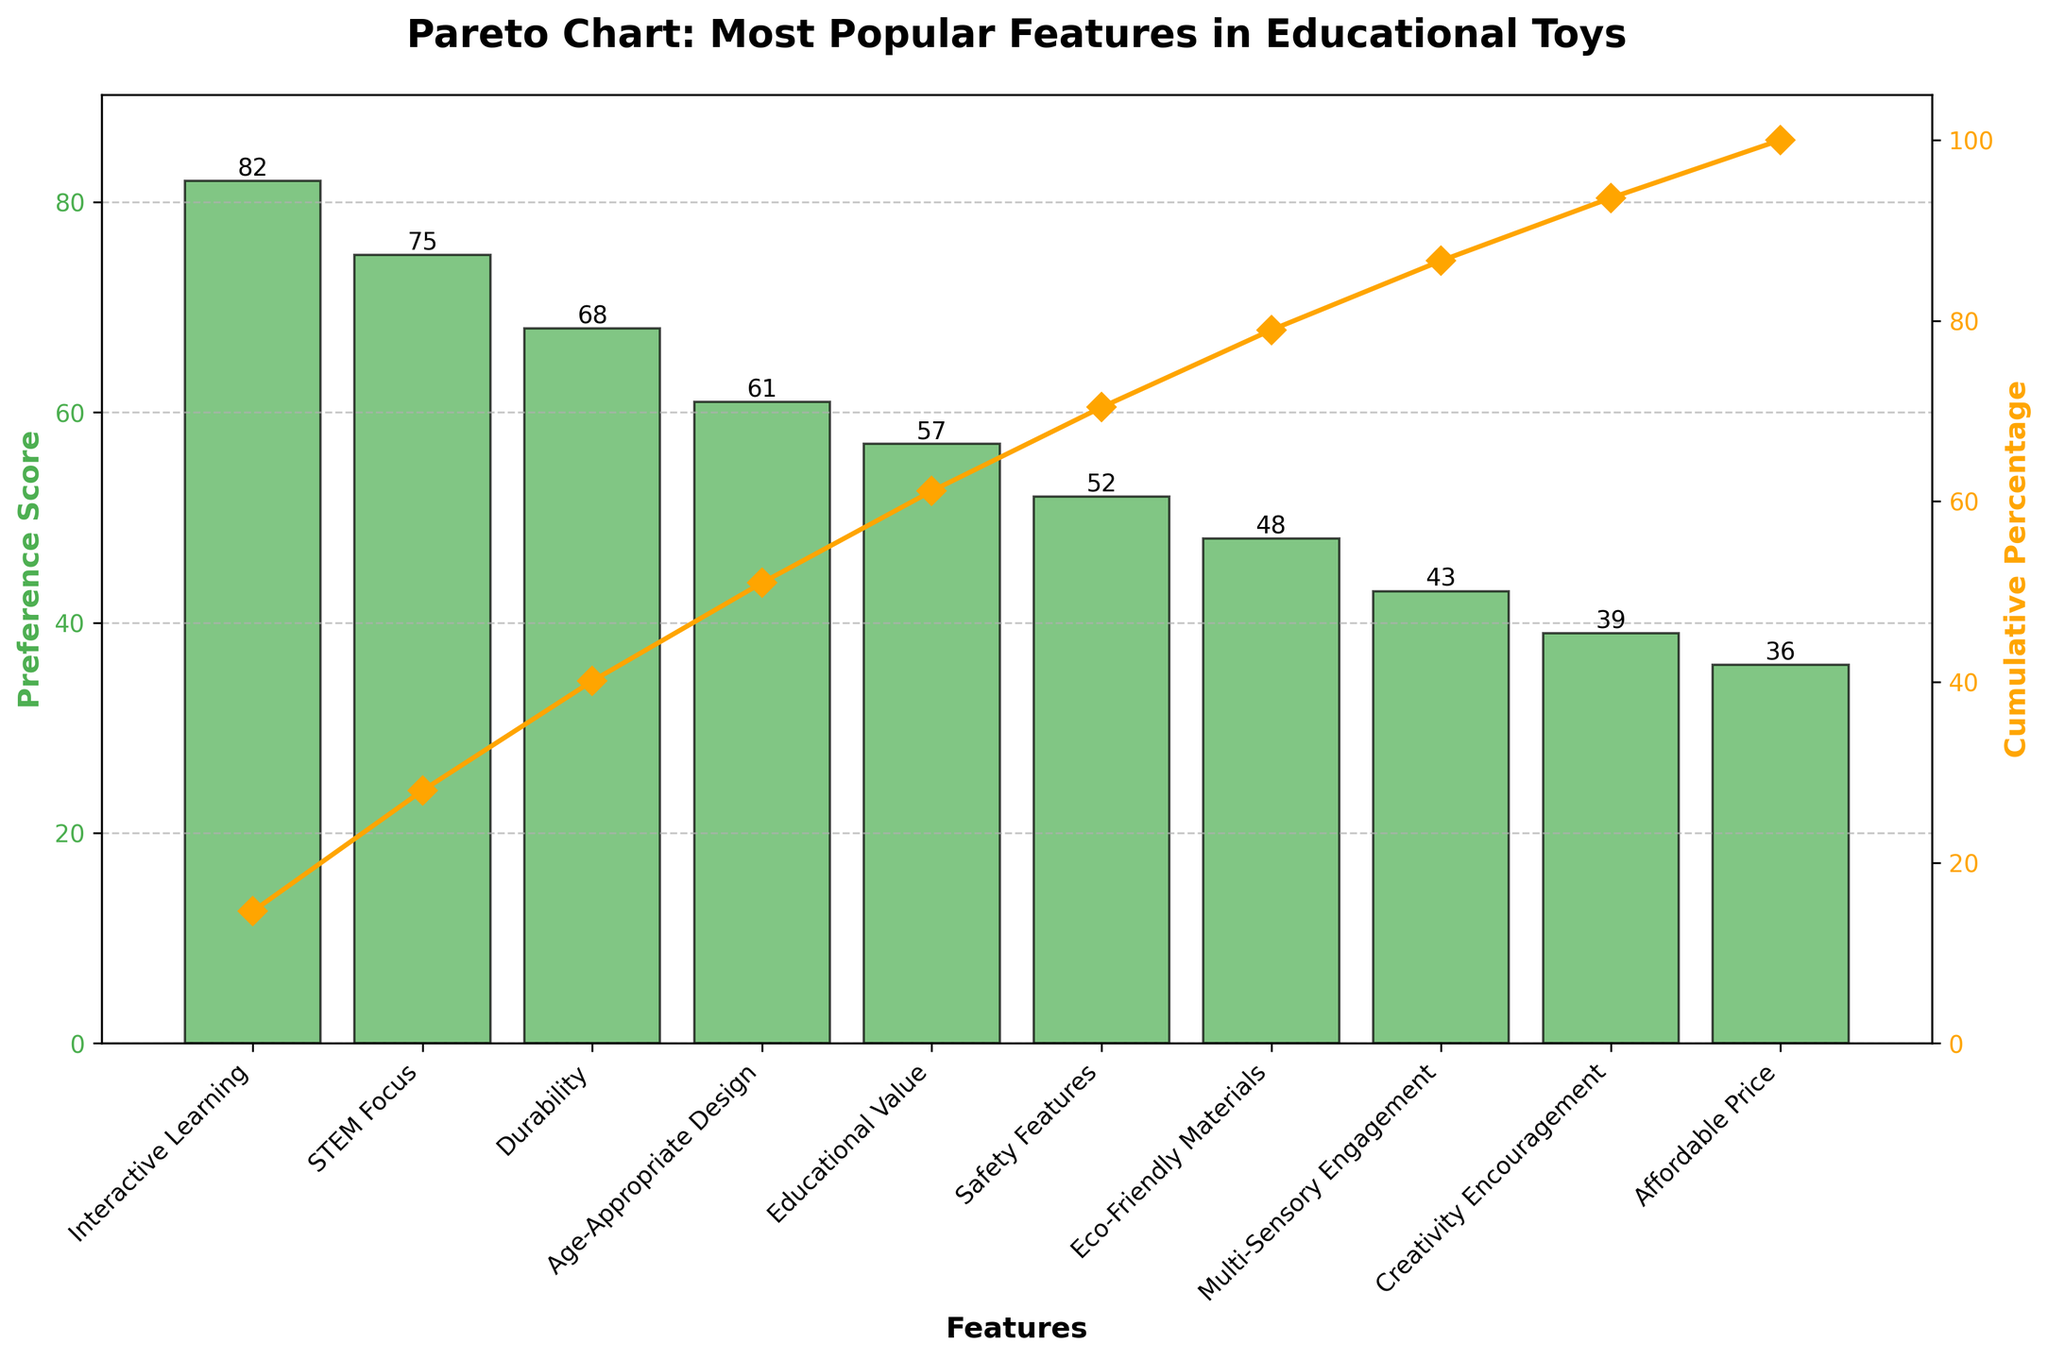What is the title of the chart? The title is the text at the top of the chart that explains its purpose or subject. In this case, it says "Pareto Chart: Most Popular Features in Educational Toys".
Answer: Pareto Chart: Most Popular Features in Educational Toys What feature has the highest preference score? The highest bar on the chart represents the feature with the highest preference score. The bar for "Interactive Learning" is the tallest.
Answer: Interactive Learning What are the colors used for the bars and the line? The bars are filled with one color, and the line is another color. The bars are green, while the line is orange.
Answer: Green and orange Which feature has a preference score of 75? Look for the bar reaching up to the score of 75 on the y-axis. The feature listed directly below this bar is "STEM Focus".
Answer: STEM Focus What is the sum of the preference scores for the top three features? To find the sum, add the preference scores of "Interactive Learning" (82), "STEM Focus" (75), and "Durability" (68). 82 + 75 + 68 = 225.
Answer: 225 How many features have a preference score higher than 50? Count the number of bars with heights that correspond to a score above 50. There are six such features.
Answer: 6 Which feature is ranked fourth in preference score? By looking at the sorted order, the fourth highest feature is the one whose bar is the fourth tallest. This is "Age-Appropriate Design".
Answer: Age-Appropriate Design What is the cumulative percentage after the first three features? Add the cumulative percentages found after the first three bars: 82 / 561 * 100 + 75 / 561 * 100 + 68 / 561 * 100 = 40.8% + 34.1% + 30% = approximately 54.7%.
Answer: 54.7% Which feature has the lowest preference score? The shortest bar on the chart indicates the feature with the lowest preference score. This is "Affordable Price".
Answer: Affordable Price What is the difference in preference score between the top feature and the bottom feature? Subtract the preference score of the lowest feature ("Affordable Price", 36) from the highest feature ("Interactive Learning", 82). 82 - 36 = 46.
Answer: 46 